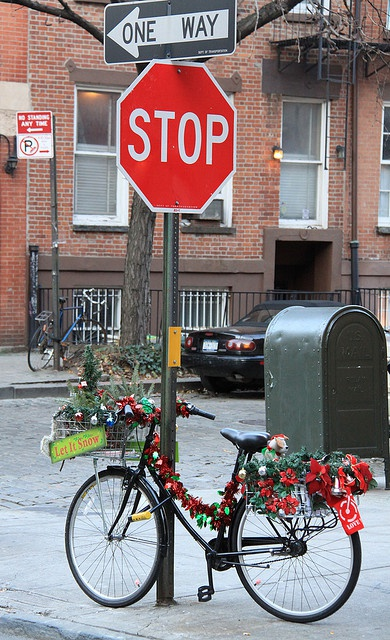Describe the objects in this image and their specific colors. I can see bicycle in black, lightgray, lightblue, and darkgray tones, stop sign in black, brown, lightgray, and lightblue tones, car in black, gray, and blue tones, and bicycle in black, gray, and darkgray tones in this image. 